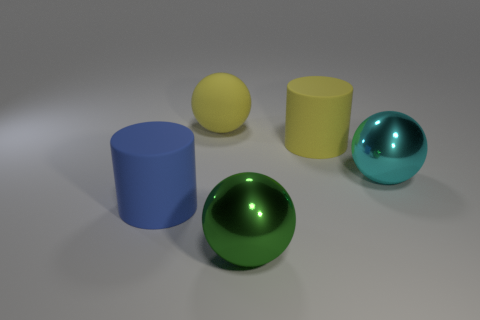Subtract all rubber balls. How many balls are left? 2 Subtract 1 balls. How many balls are left? 2 Add 2 big yellow matte balls. How many objects exist? 7 Subtract all purple spheres. Subtract all purple cylinders. How many spheres are left? 3 Subtract all balls. How many objects are left? 2 Add 3 cyan metallic things. How many cyan metallic things exist? 4 Subtract 0 red blocks. How many objects are left? 5 Subtract all small brown metallic objects. Subtract all large things. How many objects are left? 0 Add 5 large yellow things. How many large yellow things are left? 7 